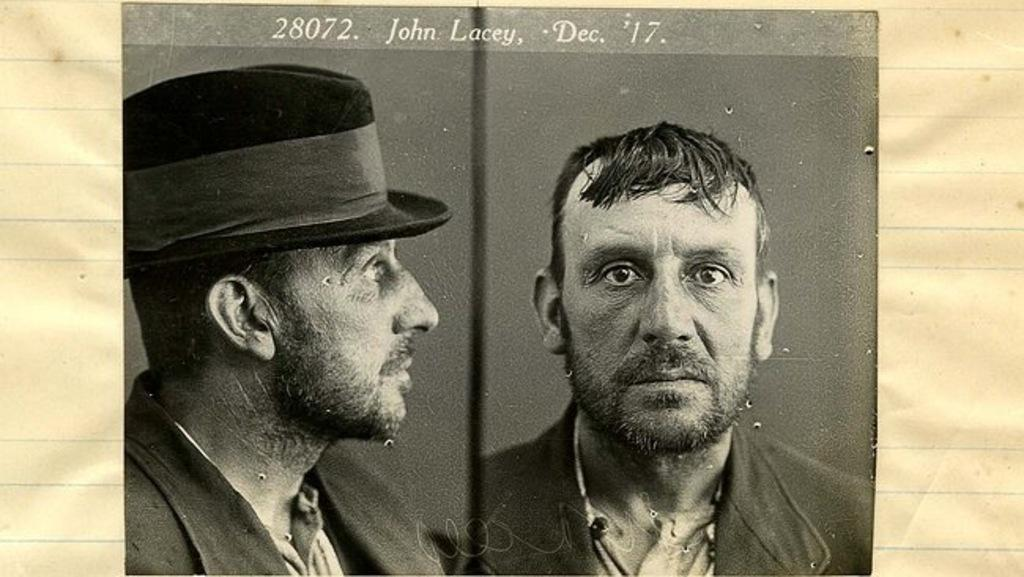What is featured in the image? There is a poster in the image. What is shown on the poster? There are two men depicted on the poster. What else can be seen on the poster besides the men? There is text present on the poster. Where is the sofa located in the image? There is no sofa present in the image. What type of doctor is depicted on the poster? There is no doctor depicted on the poster; it features two men. 